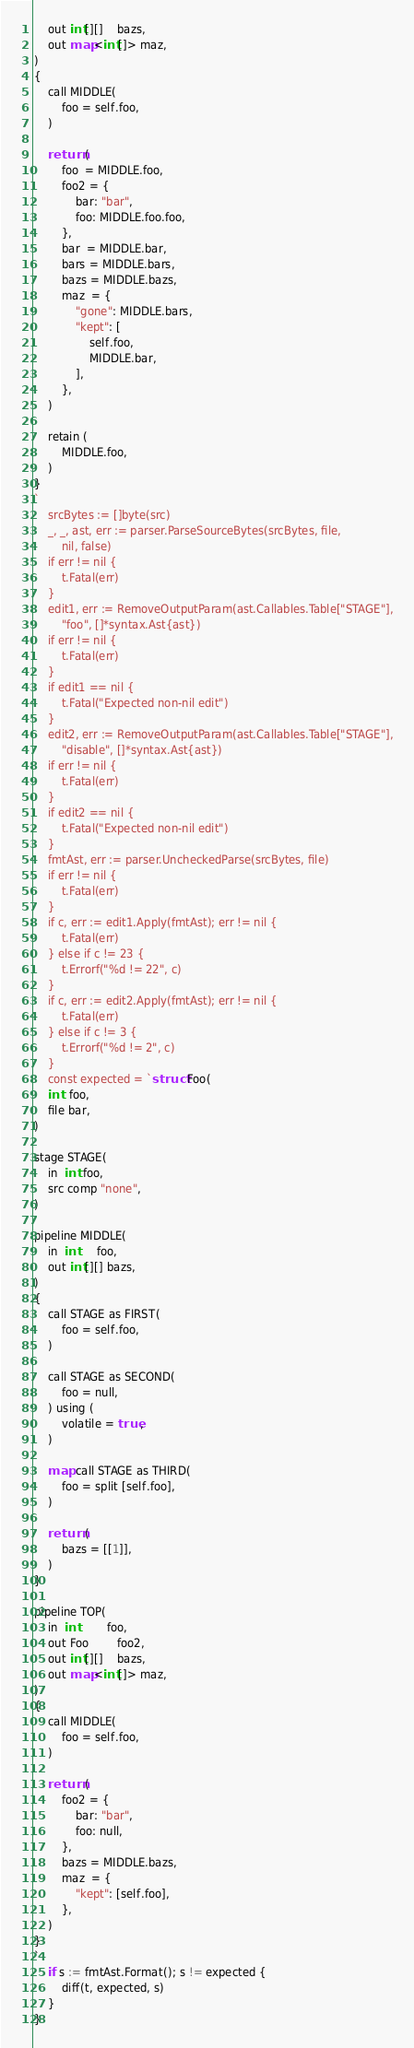<code> <loc_0><loc_0><loc_500><loc_500><_Go_>    out int[][]    bazs,
    out map<int[]> maz,
)
{
    call MIDDLE(
        foo = self.foo,
    )

    return (
        foo  = MIDDLE.foo,
        foo2 = {
            bar: "bar",
            foo: MIDDLE.foo.foo,
        },
        bar  = MIDDLE.bar,
        bars = MIDDLE.bars,
        bazs = MIDDLE.bazs,
        maz  = {
            "gone": MIDDLE.bars,
            "kept": [
                self.foo,
                MIDDLE.bar,
            ],
        },
    )

    retain (
        MIDDLE.foo,
    )
}
`
	srcBytes := []byte(src)
	_, _, ast, err := parser.ParseSourceBytes(srcBytes, file,
		nil, false)
	if err != nil {
		t.Fatal(err)
	}
	edit1, err := RemoveOutputParam(ast.Callables.Table["STAGE"],
		"foo", []*syntax.Ast{ast})
	if err != nil {
		t.Fatal(err)
	}
	if edit1 == nil {
		t.Fatal("Expected non-nil edit")
	}
	edit2, err := RemoveOutputParam(ast.Callables.Table["STAGE"],
		"disable", []*syntax.Ast{ast})
	if err != nil {
		t.Fatal(err)
	}
	if edit2 == nil {
		t.Fatal("Expected non-nil edit")
	}
	fmtAst, err := parser.UncheckedParse(srcBytes, file)
	if err != nil {
		t.Fatal(err)
	}
	if c, err := edit1.Apply(fmtAst); err != nil {
		t.Fatal(err)
	} else if c != 23 {
		t.Errorf("%d != 22", c)
	}
	if c, err := edit2.Apply(fmtAst); err != nil {
		t.Fatal(err)
	} else if c != 3 {
		t.Errorf("%d != 2", c)
	}
	const expected = `struct Foo(
    int  foo,
    file bar,
)

stage STAGE(
    in  int foo,
    src comp "none",
)

pipeline MIDDLE(
    in  int     foo,
    out int[][] bazs,
)
{
    call STAGE as FIRST(
        foo = self.foo,
    )

    call STAGE as SECOND(
        foo = null,
    ) using (
        volatile = true,
    )

    map call STAGE as THIRD(
        foo = split [self.foo],
    )

    return (
        bazs = [[1]],
    )
}

pipeline TOP(
    in  int        foo,
    out Foo        foo2,
    out int[][]    bazs,
    out map<int[]> maz,
)
{
    call MIDDLE(
        foo = self.foo,
    )

    return (
        foo2 = {
            bar: "bar",
            foo: null,
        },
        bazs = MIDDLE.bazs,
        maz  = {
            "kept": [self.foo],
        },
    )
}
`
	if s := fmtAst.Format(); s != expected {
		diff(t, expected, s)
	}
}
</code> 